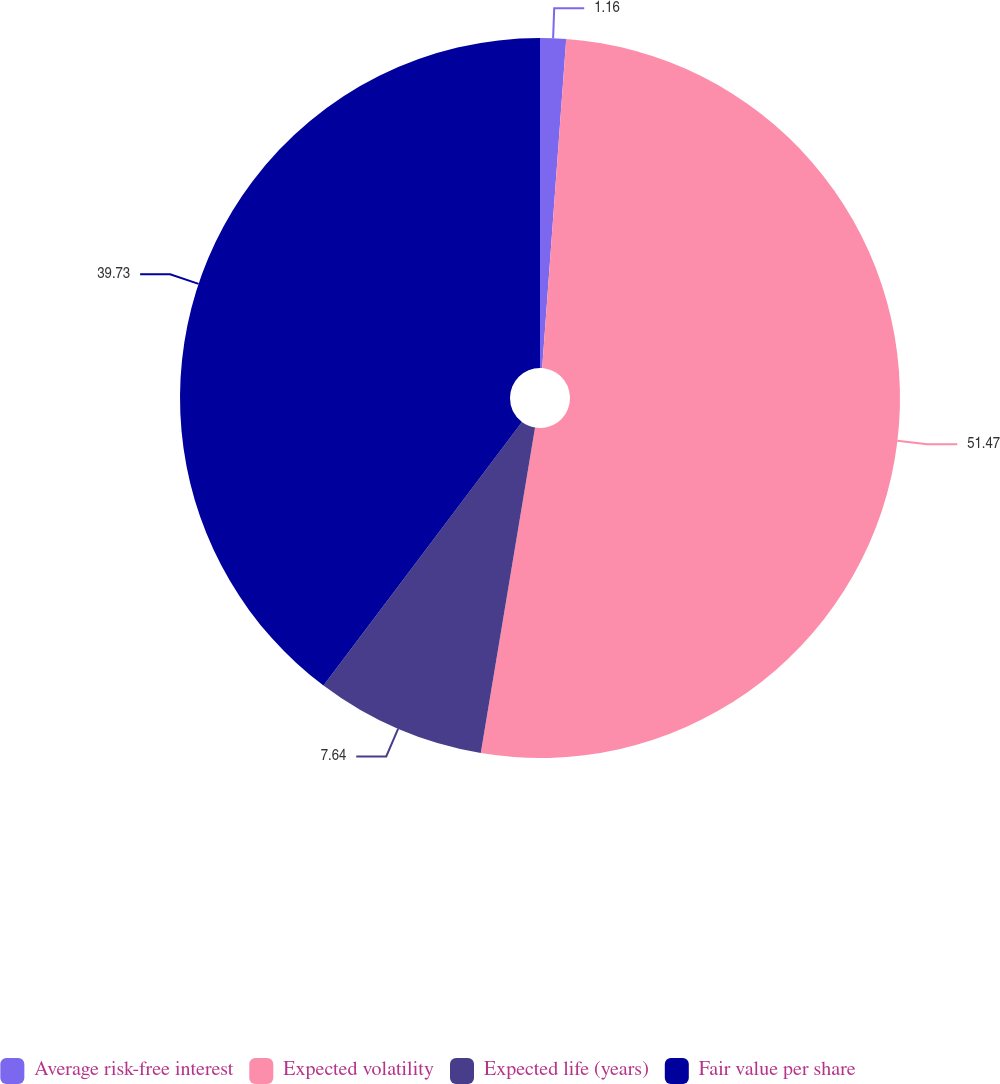<chart> <loc_0><loc_0><loc_500><loc_500><pie_chart><fcel>Average risk-free interest<fcel>Expected volatility<fcel>Expected life (years)<fcel>Fair value per share<nl><fcel>1.16%<fcel>51.47%<fcel>7.64%<fcel>39.73%<nl></chart> 